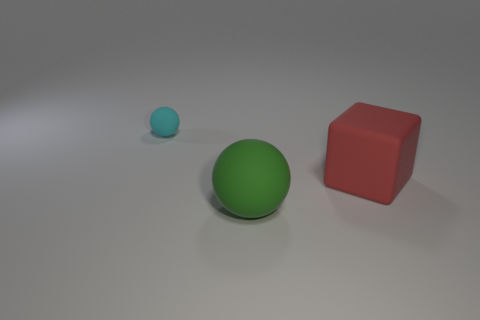Add 1 matte cubes. How many objects exist? 4 Subtract all cubes. How many objects are left? 2 Subtract 1 red cubes. How many objects are left? 2 Subtract all gray things. Subtract all red matte blocks. How many objects are left? 2 Add 1 tiny cyan objects. How many tiny cyan objects are left? 2 Add 3 small things. How many small things exist? 4 